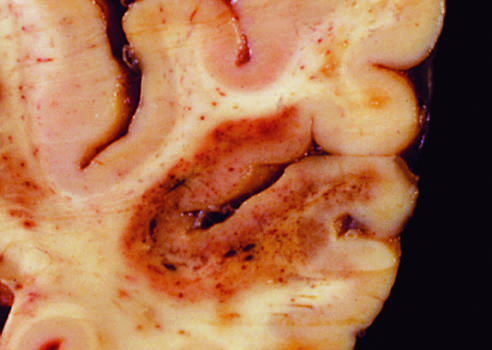s the lung biopsy specimen present in the temporal lobe?
Answer the question using a single word or phrase. No 